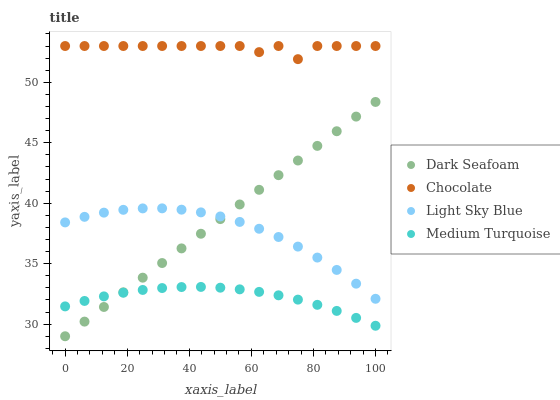Does Medium Turquoise have the minimum area under the curve?
Answer yes or no. Yes. Does Chocolate have the maximum area under the curve?
Answer yes or no. Yes. Does Light Sky Blue have the minimum area under the curve?
Answer yes or no. No. Does Light Sky Blue have the maximum area under the curve?
Answer yes or no. No. Is Dark Seafoam the smoothest?
Answer yes or no. Yes. Is Chocolate the roughest?
Answer yes or no. Yes. Is Light Sky Blue the smoothest?
Answer yes or no. No. Is Light Sky Blue the roughest?
Answer yes or no. No. Does Dark Seafoam have the lowest value?
Answer yes or no. Yes. Does Light Sky Blue have the lowest value?
Answer yes or no. No. Does Chocolate have the highest value?
Answer yes or no. Yes. Does Light Sky Blue have the highest value?
Answer yes or no. No. Is Light Sky Blue less than Chocolate?
Answer yes or no. Yes. Is Light Sky Blue greater than Medium Turquoise?
Answer yes or no. Yes. Does Light Sky Blue intersect Dark Seafoam?
Answer yes or no. Yes. Is Light Sky Blue less than Dark Seafoam?
Answer yes or no. No. Is Light Sky Blue greater than Dark Seafoam?
Answer yes or no. No. Does Light Sky Blue intersect Chocolate?
Answer yes or no. No. 